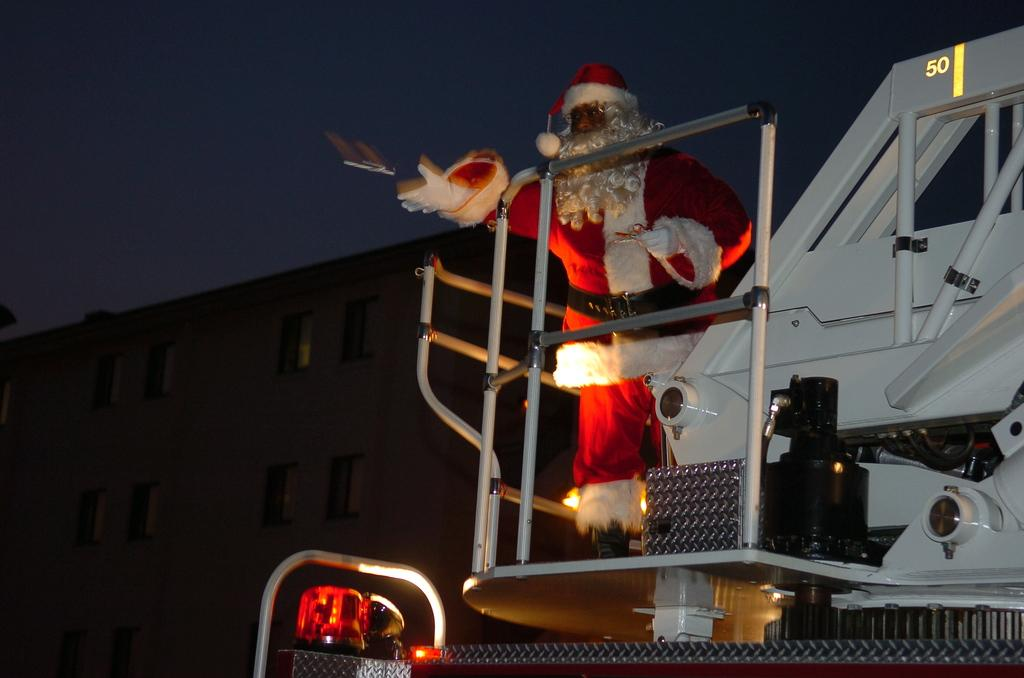What character is present in the image? There is a Santa Claus in the image. What is Santa Claus standing on? Santa Claus is standing on a vehicle. What can be seen in the background of the image? There is a building behind the vehicle. What is the voice of the ladybug in the image? There is no ladybug present in the image, so it is not possible to determine its voice. 